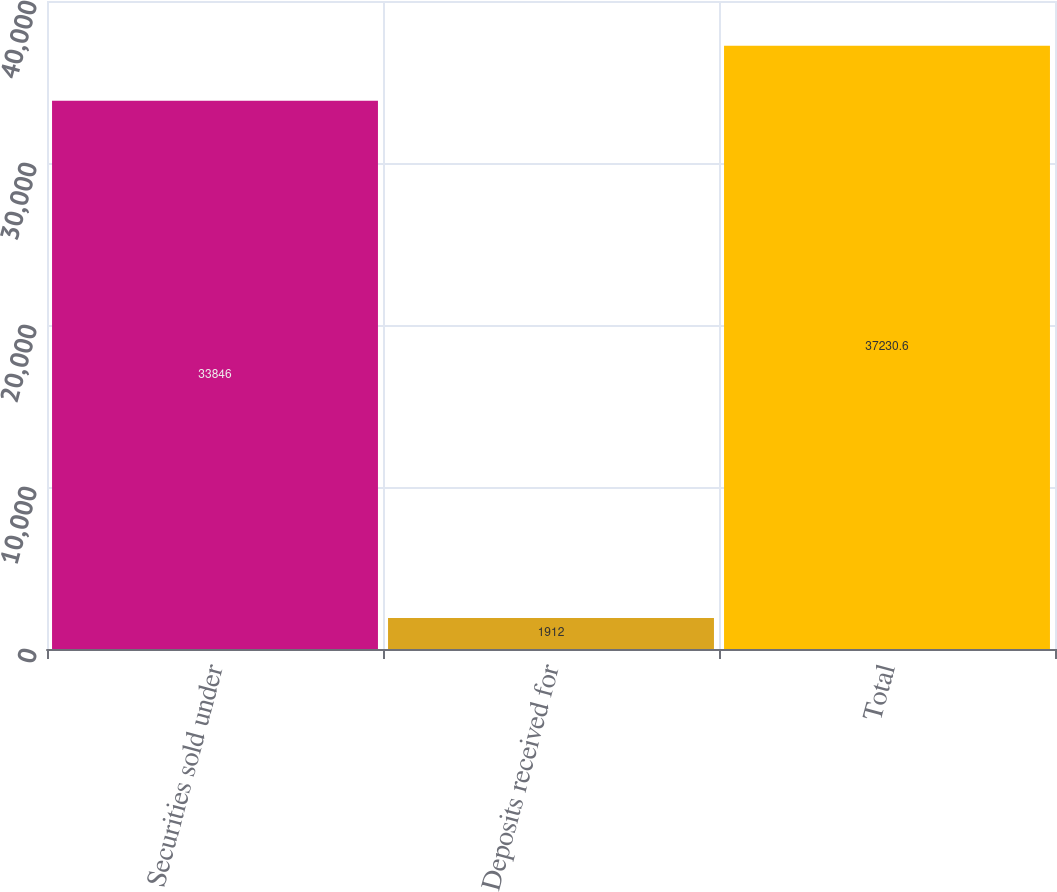Convert chart. <chart><loc_0><loc_0><loc_500><loc_500><bar_chart><fcel>Securities sold under<fcel>Deposits received for<fcel>Total<nl><fcel>33846<fcel>1912<fcel>37230.6<nl></chart> 